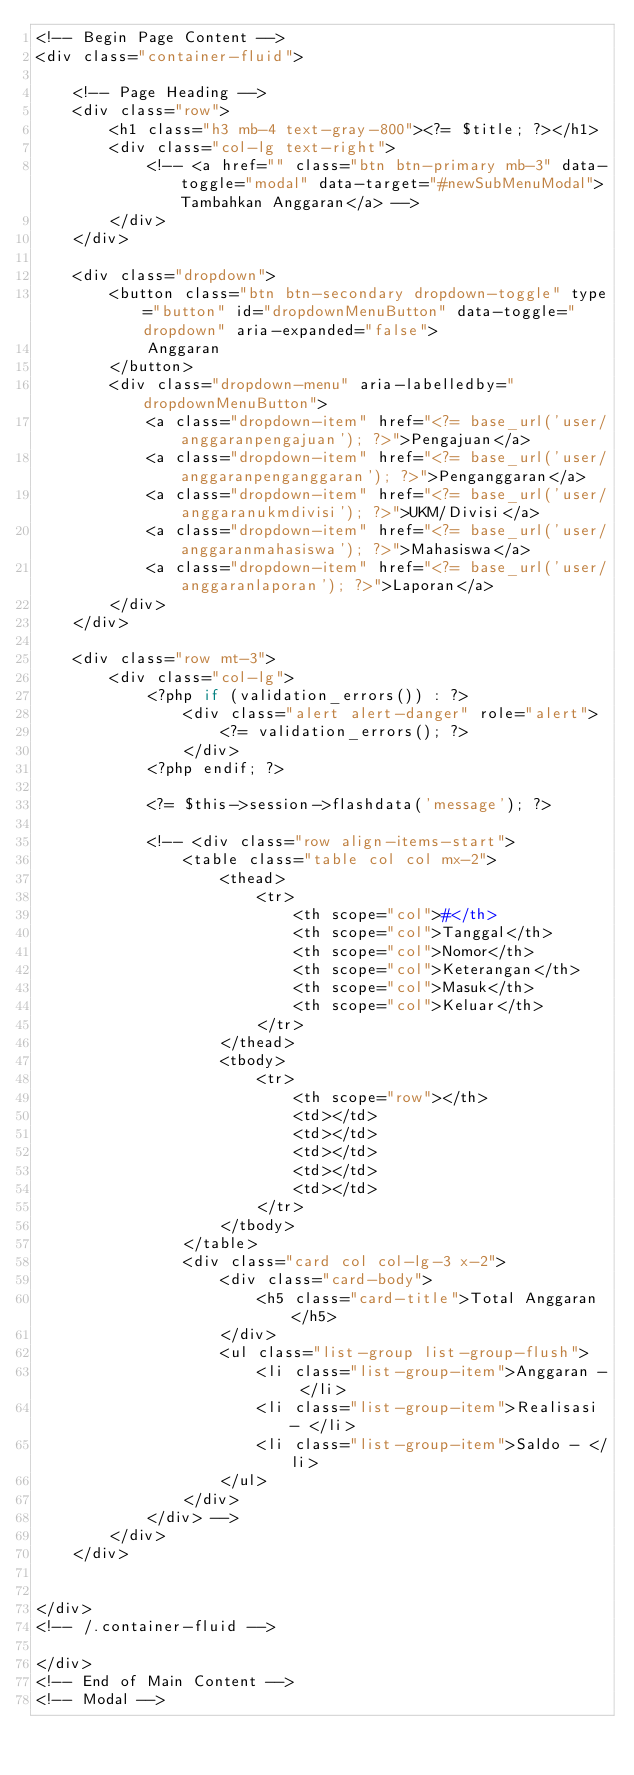Convert code to text. <code><loc_0><loc_0><loc_500><loc_500><_PHP_><!-- Begin Page Content -->
<div class="container-fluid">

    <!-- Page Heading -->
    <div class="row">
        <h1 class="h3 mb-4 text-gray-800"><?= $title; ?></h1>
        <div class="col-lg text-right">
            <!-- <a href="" class="btn btn-primary mb-3" data-toggle="modal" data-target="#newSubMenuModal">Tambahkan Anggaran</a> -->
        </div>
    </div>

    <div class="dropdown">
        <button class="btn btn-secondary dropdown-toggle" type="button" id="dropdownMenuButton" data-toggle="dropdown" aria-expanded="false">
            Anggaran
        </button>
        <div class="dropdown-menu" aria-labelledby="dropdownMenuButton">
            <a class="dropdown-item" href="<?= base_url('user/anggaranpengajuan'); ?>">Pengajuan</a>
            <a class="dropdown-item" href="<?= base_url('user/anggaranpenganggaran'); ?>">Penganggaran</a>
            <a class="dropdown-item" href="<?= base_url('user/anggaranukmdivisi'); ?>">UKM/Divisi</a>
            <a class="dropdown-item" href="<?= base_url('user/anggaranmahasiswa'); ?>">Mahasiswa</a>
            <a class="dropdown-item" href="<?= base_url('user/anggaranlaporan'); ?>">Laporan</a>
        </div>
    </div>

    <div class="row mt-3">
        <div class="col-lg">
            <?php if (validation_errors()) : ?>
                <div class="alert alert-danger" role="alert">
                    <?= validation_errors(); ?>
                </div>
            <?php endif; ?>

            <?= $this->session->flashdata('message'); ?>

            <!-- <div class="row align-items-start">
                <table class="table col col mx-2">
                    <thead>
                        <tr>
                            <th scope="col">#</th>
                            <th scope="col">Tanggal</th>
                            <th scope="col">Nomor</th>
                            <th scope="col">Keterangan</th>
                            <th scope="col">Masuk</th>
                            <th scope="col">Keluar</th>
                        </tr>
                    </thead>
                    <tbody>
                        <tr>
                            <th scope="row"></th>
                            <td></td>
                            <td></td>
                            <td></td>
                            <td></td>
                            <td></td>
                        </tr>
                    </tbody>
                </table>
                <div class="card col col-lg-3 x-2">
                    <div class="card-body">
                        <h5 class="card-title">Total Anggaran</h5>
                    </div>
                    <ul class="list-group list-group-flush">
                        <li class="list-group-item">Anggaran - </li>
                        <li class="list-group-item">Realisasi - </li>
                        <li class="list-group-item">Saldo - </li>
                    </ul>
                </div>
            </div> -->
        </div>
    </div>


</div>
<!-- /.container-fluid -->

</div>
<!-- End of Main Content -->
<!-- Modal --></code> 